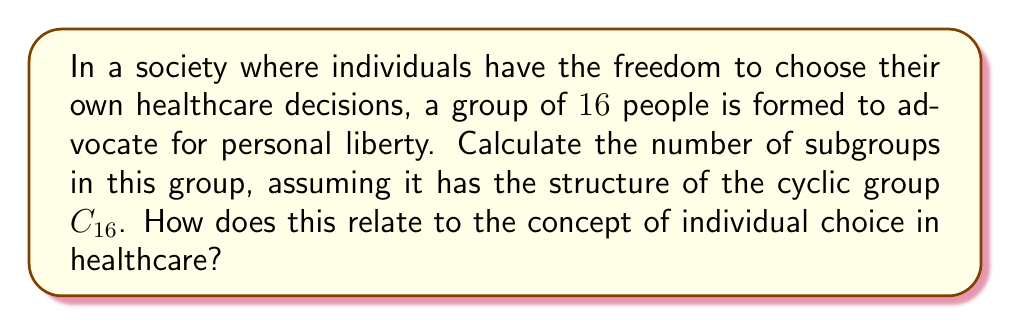Help me with this question. To solve this problem, we need to understand the structure of cyclic groups and their subgroups. The cyclic group $C_{16}$ has order 16, and its subgroups are determined by the divisors of 16.

1) First, let's find the divisors of 16:
   $1, 2, 4, 8, 16$

2) For each divisor $d$ of 16, there is exactly one subgroup of order $d$ in $C_{16}$. This is because cyclic groups have a unique subgroup for each divisor of their order.

3) Therefore, the number of subgroups in $C_{16}$ is equal to the number of divisors of 16, which is 5.

4) We can represent these subgroups as:
   $$\langle e \rangle, \langle a^8 \rangle, \langle a^4 \rangle, \langle a^2 \rangle, \langle a \rangle$$
   where $a$ is a generator of $C_{16}$ and $e$ is the identity element.

5) Relating this to individual choice in healthcare:
   - The full group $C_{16}$ represents the complete set of individual choices.
   - Each subgroup can be seen as a subset of choices that individuals might make.
   - The fact that there are multiple subgroups reflects the diversity of personal decisions in healthcare.
   - The structure of the subgroups (being determined by divisors) mirrors how personal choices often fall into distinct categories or levels of engagement with healthcare decisions.
Answer: The cyclic group $C_{16}$ has $5$ subgroups. 